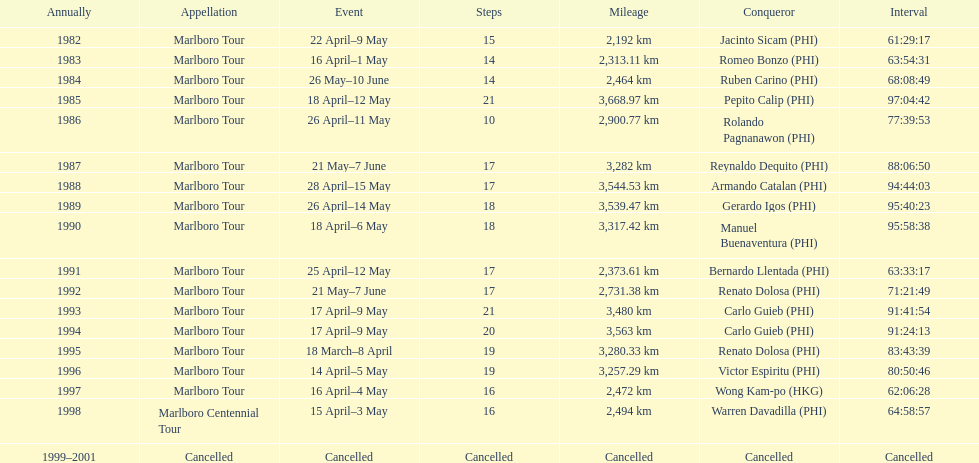What was the total number of winners before the tour was canceled? 17. 